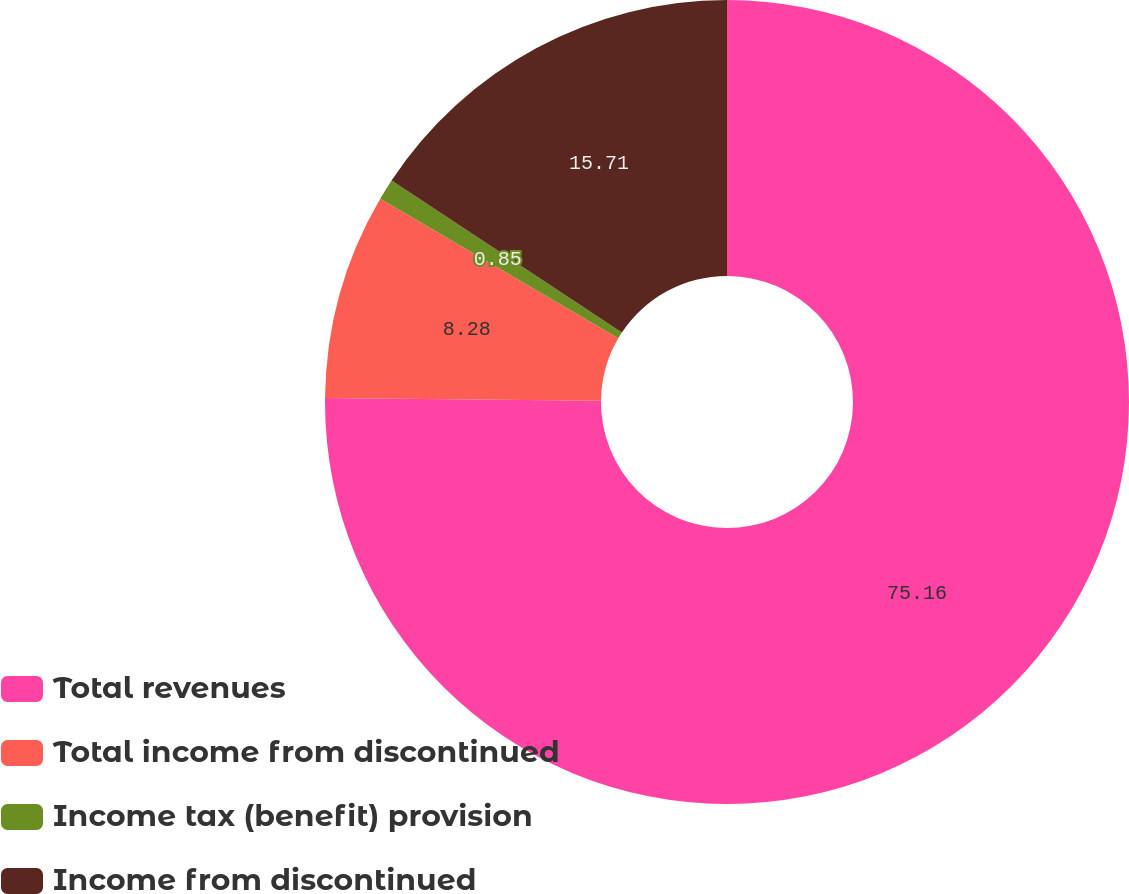Convert chart. <chart><loc_0><loc_0><loc_500><loc_500><pie_chart><fcel>Total revenues<fcel>Total income from discontinued<fcel>Income tax (benefit) provision<fcel>Income from discontinued<nl><fcel>75.17%<fcel>8.28%<fcel>0.85%<fcel>15.71%<nl></chart> 